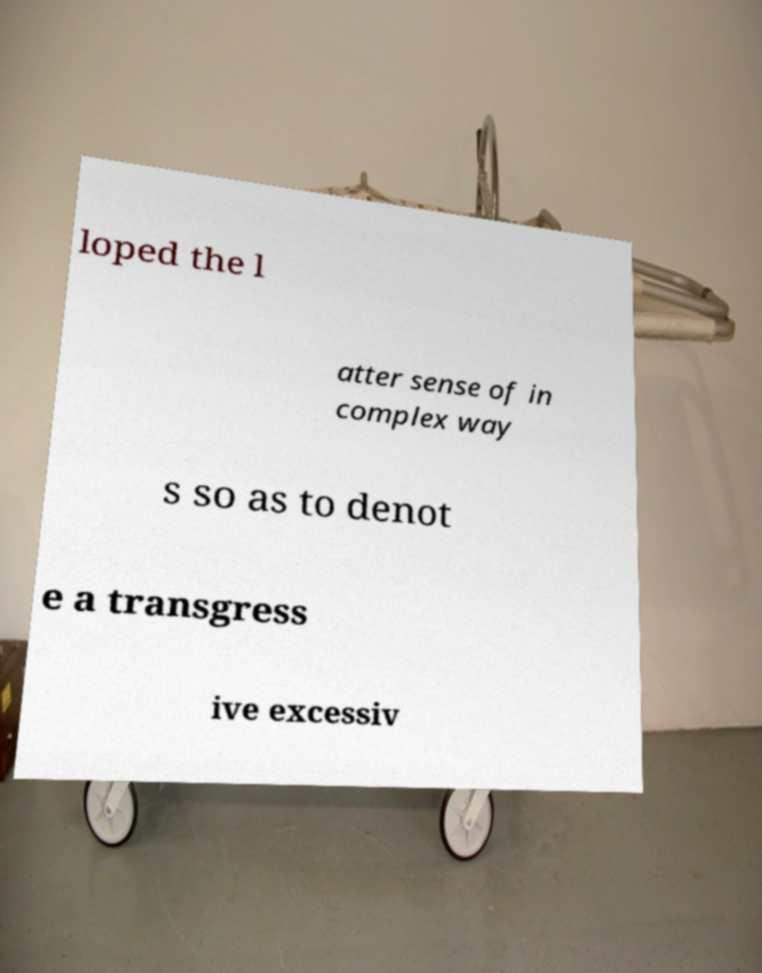Could you assist in decoding the text presented in this image and type it out clearly? loped the l atter sense of in complex way s so as to denot e a transgress ive excessiv 